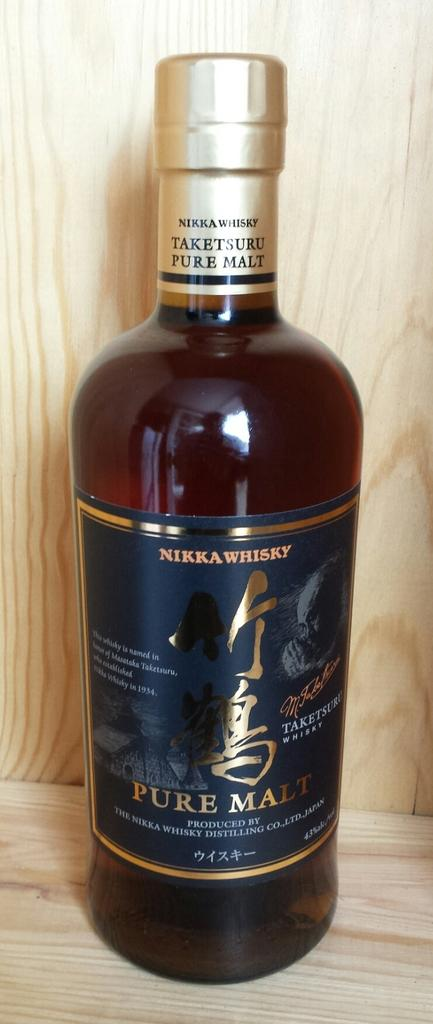<image>
Offer a succinct explanation of the picture presented. A bottle of NIKKA WHISKY from Japan titled PURE MALT. 